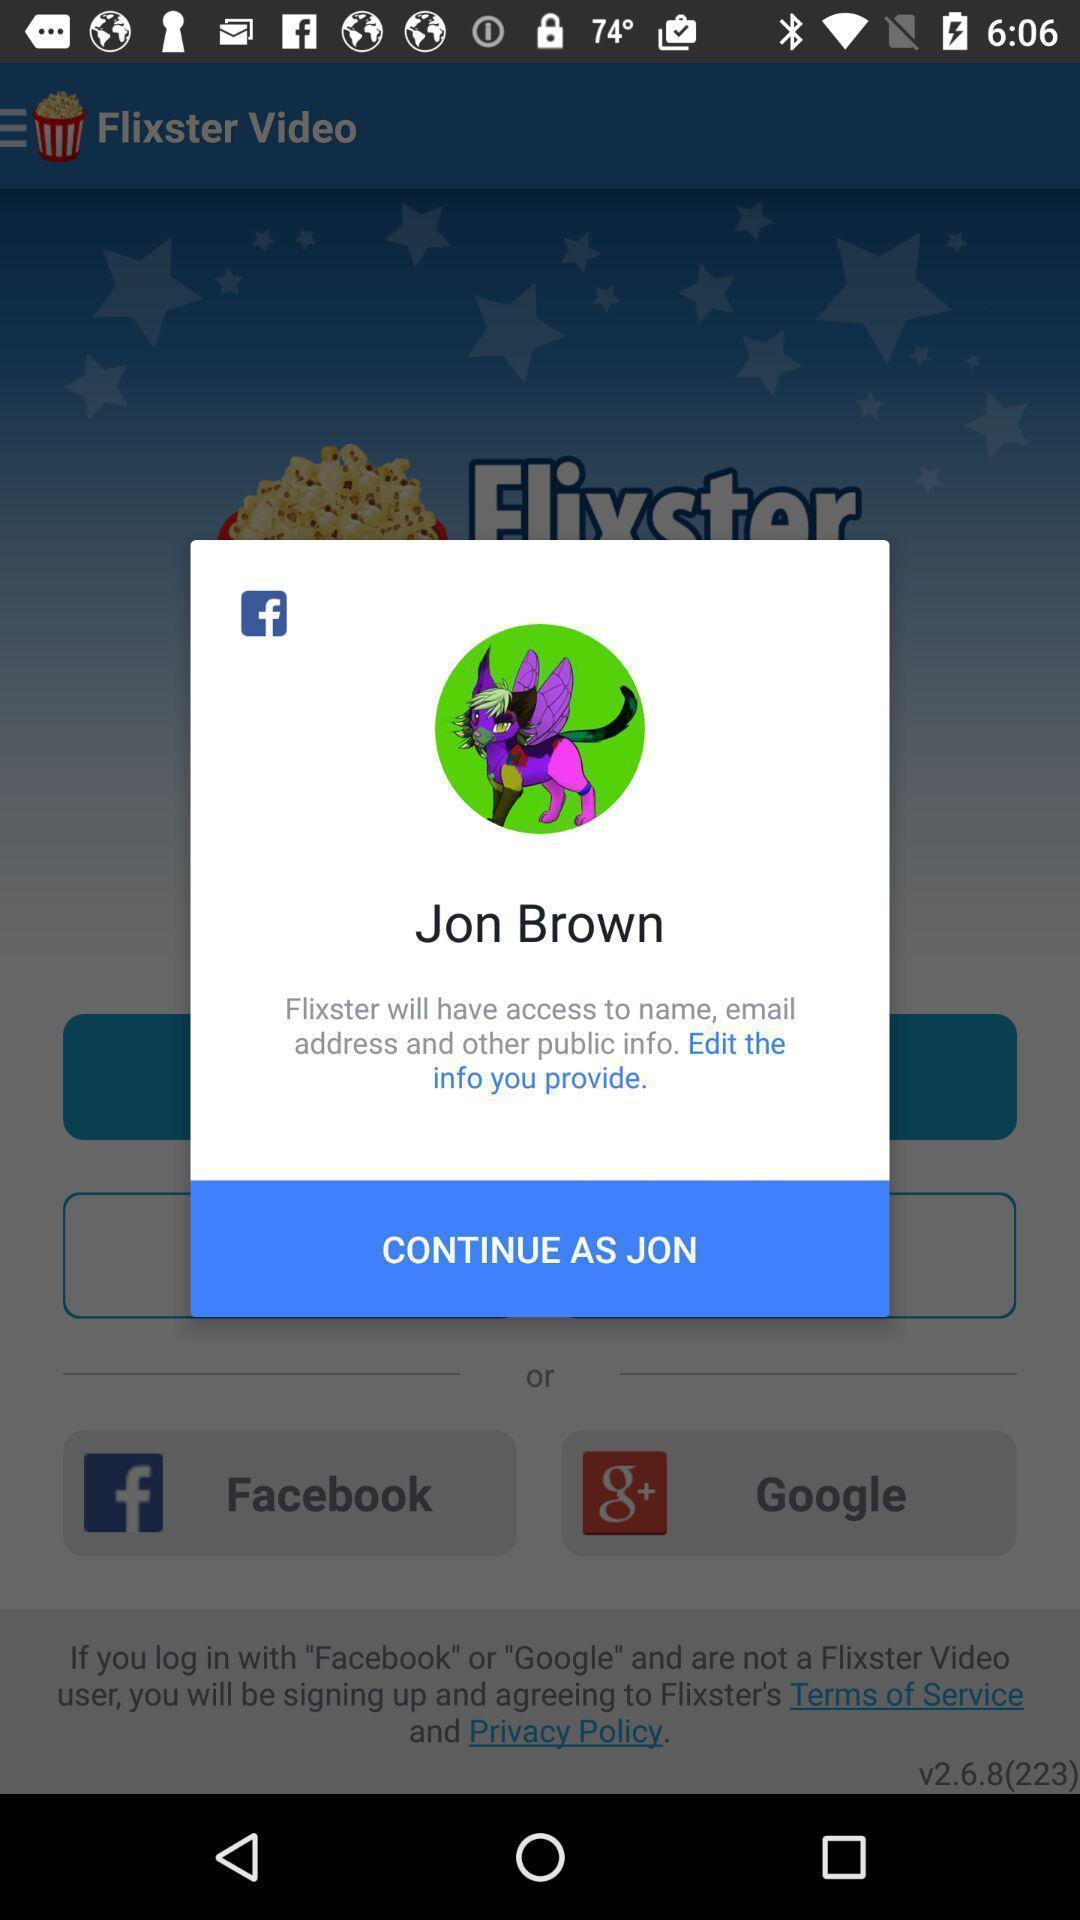Tell me about the visual elements in this screen capture. Popup showing you to continue in a video app. 